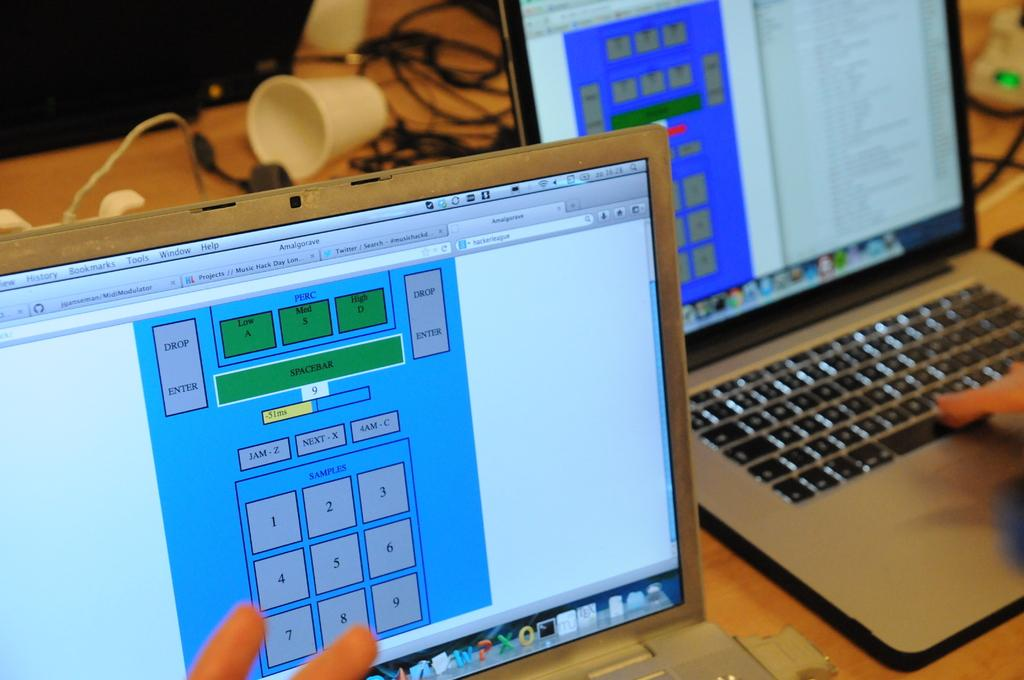<image>
Render a clear and concise summary of the photo. the number 2 is on the front of the computer screen 